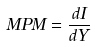Convert formula to latex. <formula><loc_0><loc_0><loc_500><loc_500>M P M = \frac { d I } { d Y }</formula> 